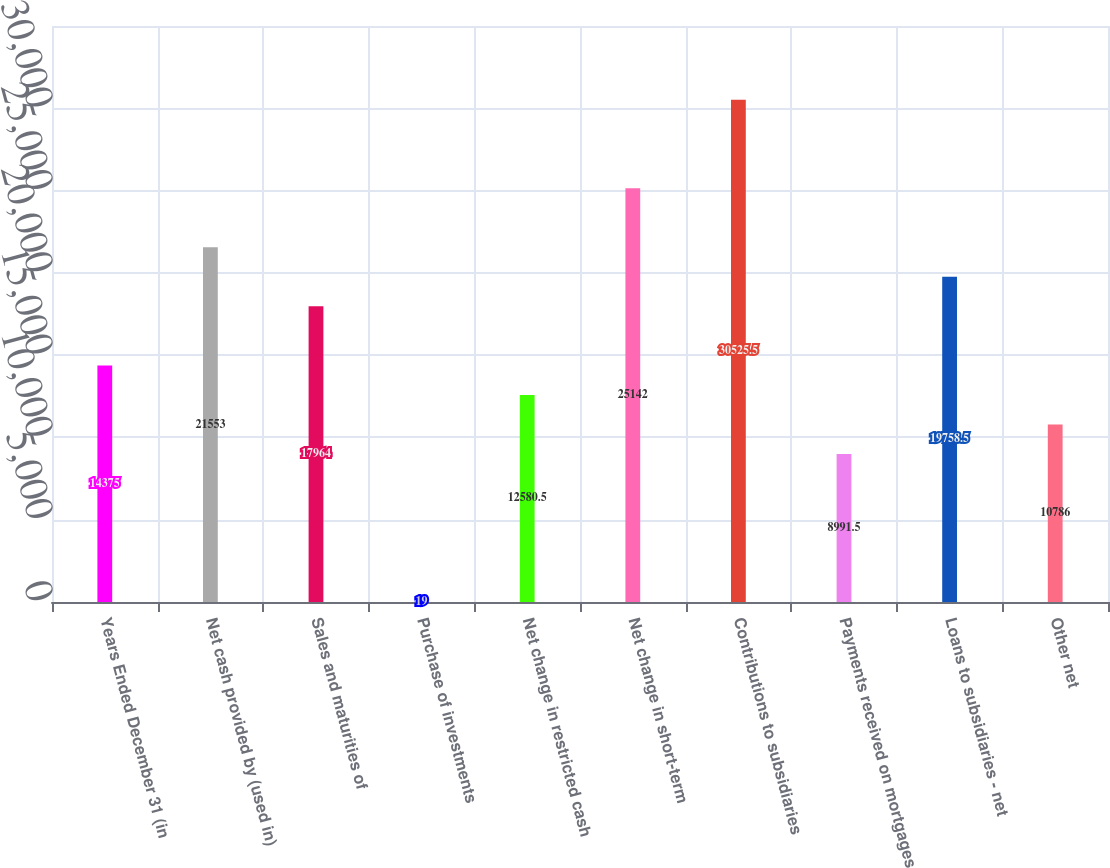Convert chart to OTSL. <chart><loc_0><loc_0><loc_500><loc_500><bar_chart><fcel>Years Ended December 31 (in<fcel>Net cash provided by (used in)<fcel>Sales and maturities of<fcel>Purchase of investments<fcel>Net change in restricted cash<fcel>Net change in short-term<fcel>Contributions to subsidiaries<fcel>Payments received on mortgages<fcel>Loans to subsidiaries - net<fcel>Other net<nl><fcel>14375<fcel>21553<fcel>17964<fcel>19<fcel>12580.5<fcel>25142<fcel>30525.5<fcel>8991.5<fcel>19758.5<fcel>10786<nl></chart> 